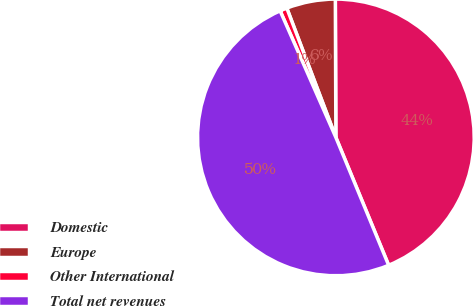Convert chart. <chart><loc_0><loc_0><loc_500><loc_500><pie_chart><fcel>Domestic<fcel>Europe<fcel>Other International<fcel>Total net revenues<nl><fcel>43.83%<fcel>5.71%<fcel>0.83%<fcel>49.63%<nl></chart> 